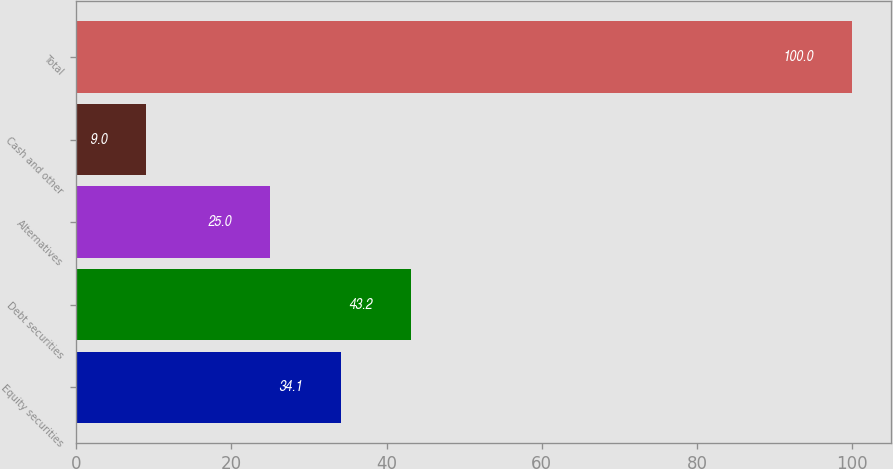Convert chart to OTSL. <chart><loc_0><loc_0><loc_500><loc_500><bar_chart><fcel>Equity securities<fcel>Debt securities<fcel>Alternatives<fcel>Cash and other<fcel>Total<nl><fcel>34.1<fcel>43.2<fcel>25<fcel>9<fcel>100<nl></chart> 